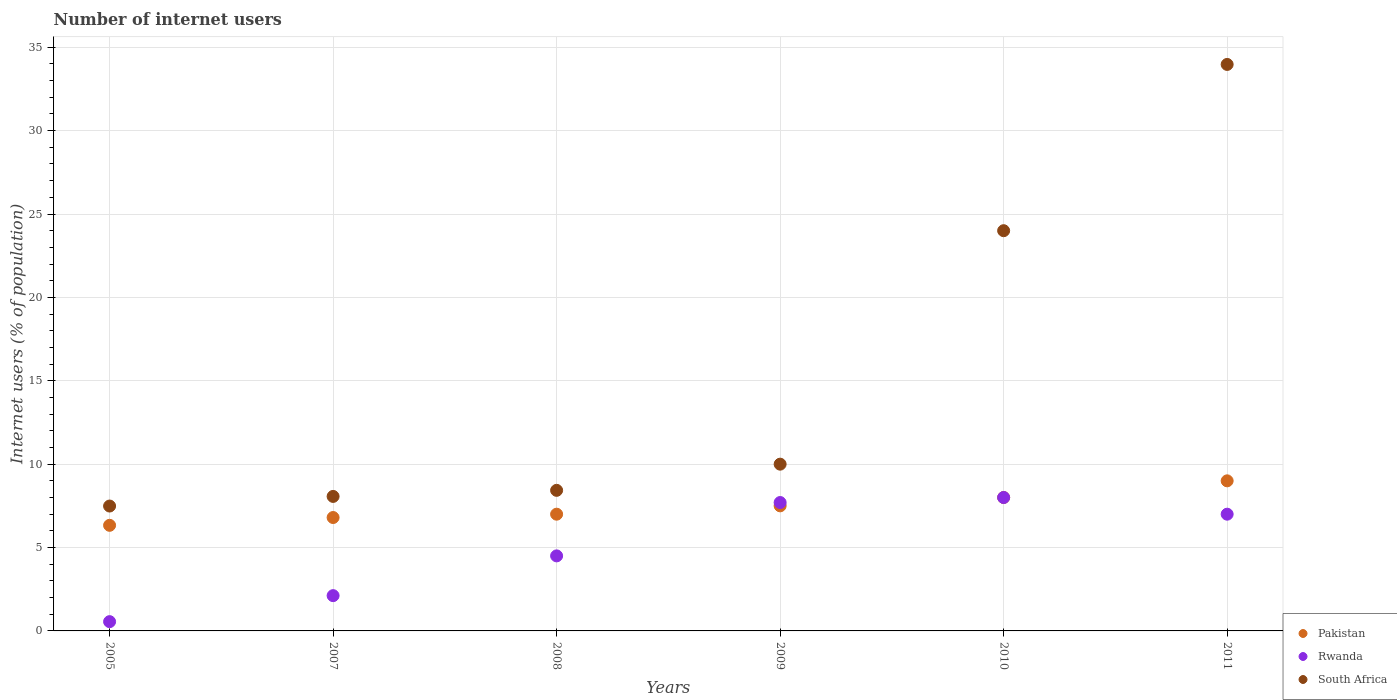How many different coloured dotlines are there?
Your answer should be compact. 3. Is the number of dotlines equal to the number of legend labels?
Offer a terse response. Yes. What is the number of internet users in South Africa in 2011?
Your answer should be compact. 33.97. Across all years, what is the maximum number of internet users in South Africa?
Keep it short and to the point. 33.97. Across all years, what is the minimum number of internet users in Pakistan?
Offer a terse response. 6.33. In which year was the number of internet users in Rwanda minimum?
Your answer should be compact. 2005. What is the total number of internet users in Pakistan in the graph?
Keep it short and to the point. 44.63. What is the difference between the number of internet users in South Africa in 2005 and that in 2007?
Your answer should be compact. -0.58. What is the difference between the number of internet users in Rwanda in 2007 and the number of internet users in South Africa in 2010?
Offer a terse response. -21.88. What is the average number of internet users in South Africa per year?
Make the answer very short. 15.33. In the year 2011, what is the difference between the number of internet users in Rwanda and number of internet users in South Africa?
Keep it short and to the point. -26.97. What is the ratio of the number of internet users in Pakistan in 2007 to that in 2008?
Offer a very short reply. 0.97. What is the difference between the highest and the lowest number of internet users in South Africa?
Your answer should be very brief. 26.48. In how many years, is the number of internet users in Rwanda greater than the average number of internet users in Rwanda taken over all years?
Offer a very short reply. 3. Does the number of internet users in Rwanda monotonically increase over the years?
Keep it short and to the point. No. Is the number of internet users in Rwanda strictly less than the number of internet users in South Africa over the years?
Your answer should be very brief. Yes. How many years are there in the graph?
Keep it short and to the point. 6. Are the values on the major ticks of Y-axis written in scientific E-notation?
Offer a very short reply. No. Does the graph contain any zero values?
Give a very brief answer. No. Does the graph contain grids?
Make the answer very short. Yes. Where does the legend appear in the graph?
Keep it short and to the point. Bottom right. How many legend labels are there?
Your answer should be very brief. 3. How are the legend labels stacked?
Provide a short and direct response. Vertical. What is the title of the graph?
Offer a very short reply. Number of internet users. Does "Singapore" appear as one of the legend labels in the graph?
Offer a terse response. No. What is the label or title of the X-axis?
Keep it short and to the point. Years. What is the label or title of the Y-axis?
Provide a short and direct response. Internet users (% of population). What is the Internet users (% of population) of Pakistan in 2005?
Offer a very short reply. 6.33. What is the Internet users (% of population) of Rwanda in 2005?
Give a very brief answer. 0.56. What is the Internet users (% of population) of South Africa in 2005?
Ensure brevity in your answer.  7.49. What is the Internet users (% of population) of Pakistan in 2007?
Your answer should be very brief. 6.8. What is the Internet users (% of population) of Rwanda in 2007?
Make the answer very short. 2.12. What is the Internet users (% of population) of South Africa in 2007?
Offer a terse response. 8.07. What is the Internet users (% of population) of Pakistan in 2008?
Ensure brevity in your answer.  7. What is the Internet users (% of population) of South Africa in 2008?
Provide a short and direct response. 8.43. What is the Internet users (% of population) of Pakistan in 2010?
Your answer should be compact. 8. What is the Internet users (% of population) of South Africa in 2011?
Give a very brief answer. 33.97. Across all years, what is the maximum Internet users (% of population) of South Africa?
Your answer should be very brief. 33.97. Across all years, what is the minimum Internet users (% of population) of Pakistan?
Keep it short and to the point. 6.33. Across all years, what is the minimum Internet users (% of population) in Rwanda?
Offer a terse response. 0.56. Across all years, what is the minimum Internet users (% of population) of South Africa?
Ensure brevity in your answer.  7.49. What is the total Internet users (% of population) of Pakistan in the graph?
Offer a very short reply. 44.63. What is the total Internet users (% of population) in Rwanda in the graph?
Offer a very short reply. 29.87. What is the total Internet users (% of population) in South Africa in the graph?
Give a very brief answer. 91.95. What is the difference between the Internet users (% of population) of Pakistan in 2005 and that in 2007?
Your answer should be very brief. -0.47. What is the difference between the Internet users (% of population) in Rwanda in 2005 and that in 2007?
Ensure brevity in your answer.  -1.56. What is the difference between the Internet users (% of population) of South Africa in 2005 and that in 2007?
Provide a short and direct response. -0.58. What is the difference between the Internet users (% of population) in Pakistan in 2005 and that in 2008?
Offer a terse response. -0.67. What is the difference between the Internet users (% of population) of Rwanda in 2005 and that in 2008?
Make the answer very short. -3.94. What is the difference between the Internet users (% of population) of South Africa in 2005 and that in 2008?
Provide a succinct answer. -0.94. What is the difference between the Internet users (% of population) of Pakistan in 2005 and that in 2009?
Keep it short and to the point. -1.17. What is the difference between the Internet users (% of population) in Rwanda in 2005 and that in 2009?
Your answer should be very brief. -7.14. What is the difference between the Internet users (% of population) in South Africa in 2005 and that in 2009?
Make the answer very short. -2.51. What is the difference between the Internet users (% of population) in Pakistan in 2005 and that in 2010?
Your answer should be very brief. -1.67. What is the difference between the Internet users (% of population) in Rwanda in 2005 and that in 2010?
Your response must be concise. -7.44. What is the difference between the Internet users (% of population) of South Africa in 2005 and that in 2010?
Offer a terse response. -16.51. What is the difference between the Internet users (% of population) in Pakistan in 2005 and that in 2011?
Keep it short and to the point. -2.67. What is the difference between the Internet users (% of population) in Rwanda in 2005 and that in 2011?
Give a very brief answer. -6.44. What is the difference between the Internet users (% of population) of South Africa in 2005 and that in 2011?
Provide a succinct answer. -26.48. What is the difference between the Internet users (% of population) in Pakistan in 2007 and that in 2008?
Make the answer very short. -0.2. What is the difference between the Internet users (% of population) in Rwanda in 2007 and that in 2008?
Ensure brevity in your answer.  -2.38. What is the difference between the Internet users (% of population) of South Africa in 2007 and that in 2008?
Ensure brevity in your answer.  -0.36. What is the difference between the Internet users (% of population) of Rwanda in 2007 and that in 2009?
Ensure brevity in your answer.  -5.58. What is the difference between the Internet users (% of population) of South Africa in 2007 and that in 2009?
Give a very brief answer. -1.93. What is the difference between the Internet users (% of population) in Pakistan in 2007 and that in 2010?
Provide a short and direct response. -1.2. What is the difference between the Internet users (% of population) of Rwanda in 2007 and that in 2010?
Give a very brief answer. -5.88. What is the difference between the Internet users (% of population) of South Africa in 2007 and that in 2010?
Offer a terse response. -15.93. What is the difference between the Internet users (% of population) in Pakistan in 2007 and that in 2011?
Your answer should be very brief. -2.2. What is the difference between the Internet users (% of population) of Rwanda in 2007 and that in 2011?
Offer a very short reply. -4.88. What is the difference between the Internet users (% of population) of South Africa in 2007 and that in 2011?
Your response must be concise. -25.9. What is the difference between the Internet users (% of population) of South Africa in 2008 and that in 2009?
Offer a terse response. -1.57. What is the difference between the Internet users (% of population) in Rwanda in 2008 and that in 2010?
Keep it short and to the point. -3.5. What is the difference between the Internet users (% of population) of South Africa in 2008 and that in 2010?
Provide a short and direct response. -15.57. What is the difference between the Internet users (% of population) in Pakistan in 2008 and that in 2011?
Keep it short and to the point. -2. What is the difference between the Internet users (% of population) of South Africa in 2008 and that in 2011?
Give a very brief answer. -25.54. What is the difference between the Internet users (% of population) of Pakistan in 2009 and that in 2011?
Your answer should be very brief. -1.5. What is the difference between the Internet users (% of population) in Rwanda in 2009 and that in 2011?
Provide a short and direct response. 0.7. What is the difference between the Internet users (% of population) in South Africa in 2009 and that in 2011?
Your response must be concise. -23.97. What is the difference between the Internet users (% of population) in South Africa in 2010 and that in 2011?
Your answer should be very brief. -9.97. What is the difference between the Internet users (% of population) of Pakistan in 2005 and the Internet users (% of population) of Rwanda in 2007?
Give a very brief answer. 4.22. What is the difference between the Internet users (% of population) of Pakistan in 2005 and the Internet users (% of population) of South Africa in 2007?
Provide a short and direct response. -1.73. What is the difference between the Internet users (% of population) in Rwanda in 2005 and the Internet users (% of population) in South Africa in 2007?
Offer a very short reply. -7.51. What is the difference between the Internet users (% of population) in Pakistan in 2005 and the Internet users (% of population) in Rwanda in 2008?
Ensure brevity in your answer.  1.83. What is the difference between the Internet users (% of population) in Pakistan in 2005 and the Internet users (% of population) in South Africa in 2008?
Give a very brief answer. -2.1. What is the difference between the Internet users (% of population) in Rwanda in 2005 and the Internet users (% of population) in South Africa in 2008?
Your response must be concise. -7.87. What is the difference between the Internet users (% of population) in Pakistan in 2005 and the Internet users (% of population) in Rwanda in 2009?
Your answer should be compact. -1.37. What is the difference between the Internet users (% of population) in Pakistan in 2005 and the Internet users (% of population) in South Africa in 2009?
Offer a terse response. -3.67. What is the difference between the Internet users (% of population) of Rwanda in 2005 and the Internet users (% of population) of South Africa in 2009?
Offer a terse response. -9.44. What is the difference between the Internet users (% of population) in Pakistan in 2005 and the Internet users (% of population) in Rwanda in 2010?
Provide a succinct answer. -1.67. What is the difference between the Internet users (% of population) in Pakistan in 2005 and the Internet users (% of population) in South Africa in 2010?
Your answer should be compact. -17.67. What is the difference between the Internet users (% of population) of Rwanda in 2005 and the Internet users (% of population) of South Africa in 2010?
Your answer should be compact. -23.44. What is the difference between the Internet users (% of population) of Pakistan in 2005 and the Internet users (% of population) of Rwanda in 2011?
Keep it short and to the point. -0.67. What is the difference between the Internet users (% of population) in Pakistan in 2005 and the Internet users (% of population) in South Africa in 2011?
Your response must be concise. -27.64. What is the difference between the Internet users (% of population) in Rwanda in 2005 and the Internet users (% of population) in South Africa in 2011?
Your answer should be very brief. -33.41. What is the difference between the Internet users (% of population) of Pakistan in 2007 and the Internet users (% of population) of South Africa in 2008?
Ensure brevity in your answer.  -1.63. What is the difference between the Internet users (% of population) in Rwanda in 2007 and the Internet users (% of population) in South Africa in 2008?
Keep it short and to the point. -6.31. What is the difference between the Internet users (% of population) in Rwanda in 2007 and the Internet users (% of population) in South Africa in 2009?
Your answer should be compact. -7.88. What is the difference between the Internet users (% of population) of Pakistan in 2007 and the Internet users (% of population) of South Africa in 2010?
Your answer should be very brief. -17.2. What is the difference between the Internet users (% of population) in Rwanda in 2007 and the Internet users (% of population) in South Africa in 2010?
Keep it short and to the point. -21.88. What is the difference between the Internet users (% of population) in Pakistan in 2007 and the Internet users (% of population) in Rwanda in 2011?
Offer a very short reply. -0.2. What is the difference between the Internet users (% of population) of Pakistan in 2007 and the Internet users (% of population) of South Africa in 2011?
Your answer should be compact. -27.17. What is the difference between the Internet users (% of population) of Rwanda in 2007 and the Internet users (% of population) of South Africa in 2011?
Offer a terse response. -31.85. What is the difference between the Internet users (% of population) of Pakistan in 2008 and the Internet users (% of population) of Rwanda in 2009?
Keep it short and to the point. -0.7. What is the difference between the Internet users (% of population) of Pakistan in 2008 and the Internet users (% of population) of South Africa in 2010?
Make the answer very short. -17. What is the difference between the Internet users (% of population) of Rwanda in 2008 and the Internet users (% of population) of South Africa in 2010?
Give a very brief answer. -19.5. What is the difference between the Internet users (% of population) of Pakistan in 2008 and the Internet users (% of population) of South Africa in 2011?
Provide a short and direct response. -26.97. What is the difference between the Internet users (% of population) of Rwanda in 2008 and the Internet users (% of population) of South Africa in 2011?
Provide a succinct answer. -29.47. What is the difference between the Internet users (% of population) of Pakistan in 2009 and the Internet users (% of population) of South Africa in 2010?
Offer a very short reply. -16.5. What is the difference between the Internet users (% of population) in Rwanda in 2009 and the Internet users (% of population) in South Africa in 2010?
Your response must be concise. -16.3. What is the difference between the Internet users (% of population) in Pakistan in 2009 and the Internet users (% of population) in Rwanda in 2011?
Your response must be concise. 0.5. What is the difference between the Internet users (% of population) of Pakistan in 2009 and the Internet users (% of population) of South Africa in 2011?
Provide a short and direct response. -26.47. What is the difference between the Internet users (% of population) of Rwanda in 2009 and the Internet users (% of population) of South Africa in 2011?
Make the answer very short. -26.27. What is the difference between the Internet users (% of population) of Pakistan in 2010 and the Internet users (% of population) of South Africa in 2011?
Offer a terse response. -25.97. What is the difference between the Internet users (% of population) of Rwanda in 2010 and the Internet users (% of population) of South Africa in 2011?
Your response must be concise. -25.97. What is the average Internet users (% of population) in Pakistan per year?
Your answer should be very brief. 7.44. What is the average Internet users (% of population) in Rwanda per year?
Provide a succinct answer. 4.98. What is the average Internet users (% of population) of South Africa per year?
Your answer should be very brief. 15.33. In the year 2005, what is the difference between the Internet users (% of population) of Pakistan and Internet users (% of population) of Rwanda?
Your response must be concise. 5.78. In the year 2005, what is the difference between the Internet users (% of population) of Pakistan and Internet users (% of population) of South Africa?
Ensure brevity in your answer.  -1.16. In the year 2005, what is the difference between the Internet users (% of population) in Rwanda and Internet users (% of population) in South Africa?
Your response must be concise. -6.93. In the year 2007, what is the difference between the Internet users (% of population) of Pakistan and Internet users (% of population) of Rwanda?
Your response must be concise. 4.68. In the year 2007, what is the difference between the Internet users (% of population) of Pakistan and Internet users (% of population) of South Africa?
Ensure brevity in your answer.  -1.27. In the year 2007, what is the difference between the Internet users (% of population) of Rwanda and Internet users (% of population) of South Africa?
Your answer should be very brief. -5.95. In the year 2008, what is the difference between the Internet users (% of population) in Pakistan and Internet users (% of population) in Rwanda?
Your answer should be compact. 2.5. In the year 2008, what is the difference between the Internet users (% of population) of Pakistan and Internet users (% of population) of South Africa?
Your answer should be compact. -1.43. In the year 2008, what is the difference between the Internet users (% of population) in Rwanda and Internet users (% of population) in South Africa?
Offer a terse response. -3.93. In the year 2009, what is the difference between the Internet users (% of population) of Pakistan and Internet users (% of population) of Rwanda?
Offer a terse response. -0.2. In the year 2009, what is the difference between the Internet users (% of population) of Pakistan and Internet users (% of population) of South Africa?
Your answer should be compact. -2.5. In the year 2009, what is the difference between the Internet users (% of population) in Rwanda and Internet users (% of population) in South Africa?
Make the answer very short. -2.3. In the year 2010, what is the difference between the Internet users (% of population) in Pakistan and Internet users (% of population) in Rwanda?
Your answer should be compact. 0. In the year 2010, what is the difference between the Internet users (% of population) of Rwanda and Internet users (% of population) of South Africa?
Ensure brevity in your answer.  -16. In the year 2011, what is the difference between the Internet users (% of population) in Pakistan and Internet users (% of population) in South Africa?
Offer a terse response. -24.97. In the year 2011, what is the difference between the Internet users (% of population) in Rwanda and Internet users (% of population) in South Africa?
Keep it short and to the point. -26.97. What is the ratio of the Internet users (% of population) of Pakistan in 2005 to that in 2007?
Provide a succinct answer. 0.93. What is the ratio of the Internet users (% of population) in Rwanda in 2005 to that in 2007?
Provide a succinct answer. 0.26. What is the ratio of the Internet users (% of population) of South Africa in 2005 to that in 2007?
Your answer should be very brief. 0.93. What is the ratio of the Internet users (% of population) of Pakistan in 2005 to that in 2008?
Provide a succinct answer. 0.9. What is the ratio of the Internet users (% of population) of Rwanda in 2005 to that in 2008?
Provide a succinct answer. 0.12. What is the ratio of the Internet users (% of population) of South Africa in 2005 to that in 2008?
Your answer should be compact. 0.89. What is the ratio of the Internet users (% of population) in Pakistan in 2005 to that in 2009?
Your answer should be compact. 0.84. What is the ratio of the Internet users (% of population) in Rwanda in 2005 to that in 2009?
Ensure brevity in your answer.  0.07. What is the ratio of the Internet users (% of population) in South Africa in 2005 to that in 2009?
Keep it short and to the point. 0.75. What is the ratio of the Internet users (% of population) of Pakistan in 2005 to that in 2010?
Give a very brief answer. 0.79. What is the ratio of the Internet users (% of population) of Rwanda in 2005 to that in 2010?
Ensure brevity in your answer.  0.07. What is the ratio of the Internet users (% of population) of South Africa in 2005 to that in 2010?
Your answer should be very brief. 0.31. What is the ratio of the Internet users (% of population) of Pakistan in 2005 to that in 2011?
Your response must be concise. 0.7. What is the ratio of the Internet users (% of population) in Rwanda in 2005 to that in 2011?
Your answer should be very brief. 0.08. What is the ratio of the Internet users (% of population) of South Africa in 2005 to that in 2011?
Provide a succinct answer. 0.22. What is the ratio of the Internet users (% of population) of Pakistan in 2007 to that in 2008?
Your response must be concise. 0.97. What is the ratio of the Internet users (% of population) in Rwanda in 2007 to that in 2008?
Keep it short and to the point. 0.47. What is the ratio of the Internet users (% of population) in South Africa in 2007 to that in 2008?
Provide a succinct answer. 0.96. What is the ratio of the Internet users (% of population) in Pakistan in 2007 to that in 2009?
Ensure brevity in your answer.  0.91. What is the ratio of the Internet users (% of population) in Rwanda in 2007 to that in 2009?
Provide a short and direct response. 0.27. What is the ratio of the Internet users (% of population) in South Africa in 2007 to that in 2009?
Your answer should be compact. 0.81. What is the ratio of the Internet users (% of population) of Rwanda in 2007 to that in 2010?
Give a very brief answer. 0.26. What is the ratio of the Internet users (% of population) of South Africa in 2007 to that in 2010?
Your response must be concise. 0.34. What is the ratio of the Internet users (% of population) in Pakistan in 2007 to that in 2011?
Your answer should be compact. 0.76. What is the ratio of the Internet users (% of population) in Rwanda in 2007 to that in 2011?
Your response must be concise. 0.3. What is the ratio of the Internet users (% of population) of South Africa in 2007 to that in 2011?
Make the answer very short. 0.24. What is the ratio of the Internet users (% of population) in Pakistan in 2008 to that in 2009?
Your response must be concise. 0.93. What is the ratio of the Internet users (% of population) in Rwanda in 2008 to that in 2009?
Your answer should be compact. 0.58. What is the ratio of the Internet users (% of population) of South Africa in 2008 to that in 2009?
Provide a short and direct response. 0.84. What is the ratio of the Internet users (% of population) of Rwanda in 2008 to that in 2010?
Keep it short and to the point. 0.56. What is the ratio of the Internet users (% of population) of South Africa in 2008 to that in 2010?
Make the answer very short. 0.35. What is the ratio of the Internet users (% of population) in Rwanda in 2008 to that in 2011?
Make the answer very short. 0.64. What is the ratio of the Internet users (% of population) of South Africa in 2008 to that in 2011?
Give a very brief answer. 0.25. What is the ratio of the Internet users (% of population) of Pakistan in 2009 to that in 2010?
Your response must be concise. 0.94. What is the ratio of the Internet users (% of population) in Rwanda in 2009 to that in 2010?
Offer a terse response. 0.96. What is the ratio of the Internet users (% of population) of South Africa in 2009 to that in 2010?
Keep it short and to the point. 0.42. What is the ratio of the Internet users (% of population) in South Africa in 2009 to that in 2011?
Make the answer very short. 0.29. What is the ratio of the Internet users (% of population) in South Africa in 2010 to that in 2011?
Your answer should be compact. 0.71. What is the difference between the highest and the second highest Internet users (% of population) of South Africa?
Offer a terse response. 9.97. What is the difference between the highest and the lowest Internet users (% of population) in Pakistan?
Ensure brevity in your answer.  2.67. What is the difference between the highest and the lowest Internet users (% of population) in Rwanda?
Provide a short and direct response. 7.44. What is the difference between the highest and the lowest Internet users (% of population) of South Africa?
Offer a terse response. 26.48. 